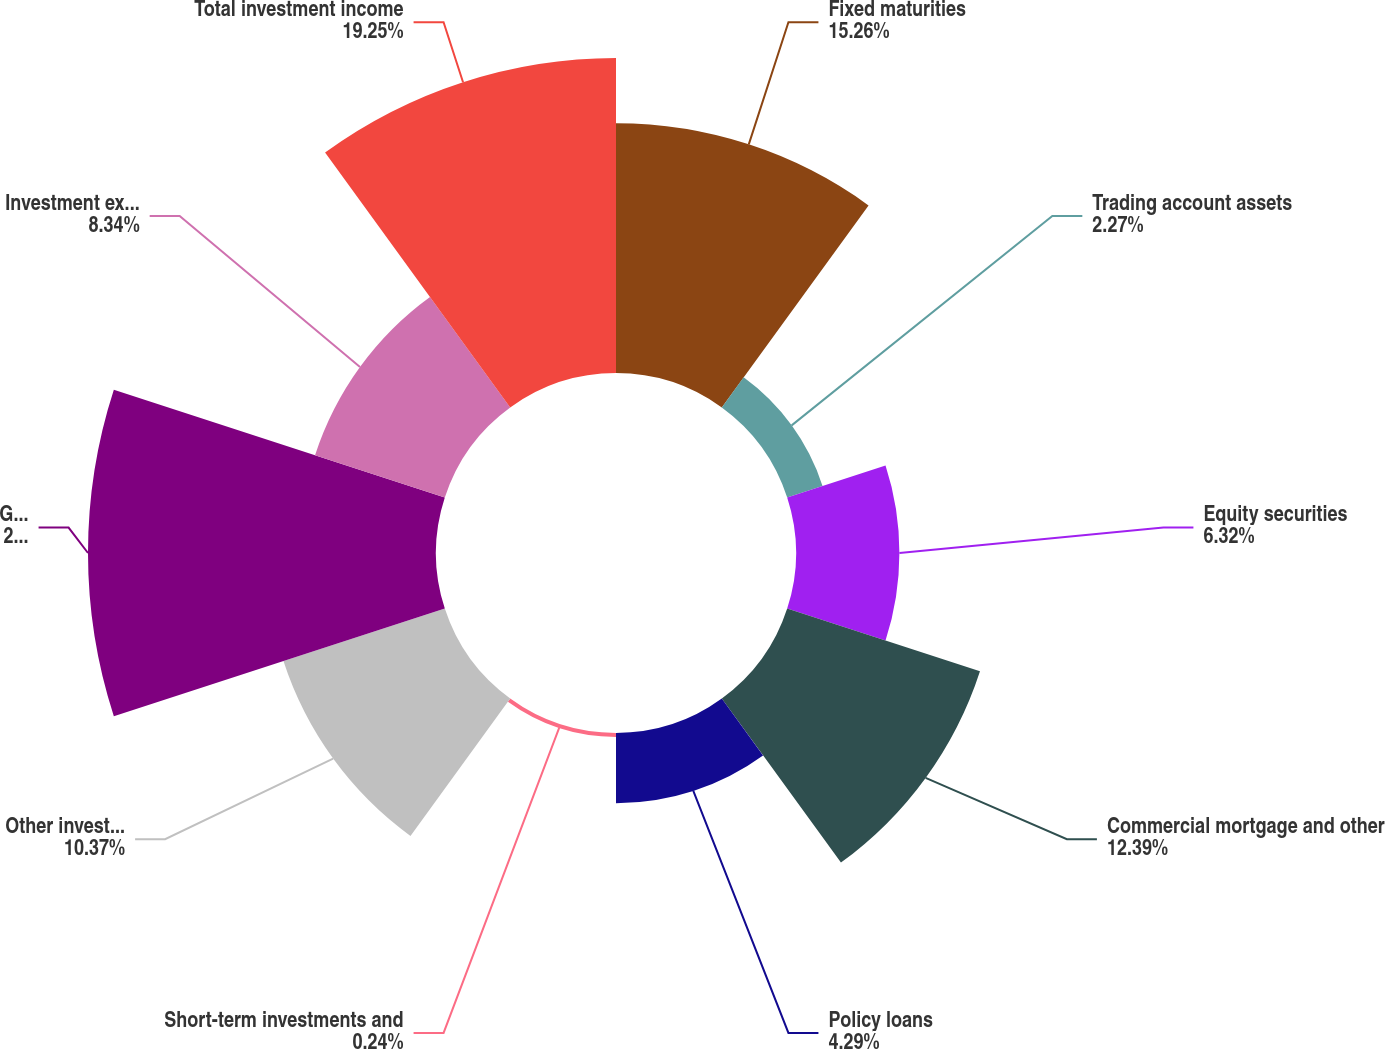<chart> <loc_0><loc_0><loc_500><loc_500><pie_chart><fcel>Fixed maturities<fcel>Trading account assets<fcel>Equity securities<fcel>Commercial mortgage and other<fcel>Policy loans<fcel>Short-term investments and<fcel>Other investments<fcel>Gross investment income before<fcel>Investment expenses<fcel>Total investment income<nl><fcel>15.26%<fcel>2.27%<fcel>6.32%<fcel>12.39%<fcel>4.29%<fcel>0.24%<fcel>10.37%<fcel>21.27%<fcel>8.34%<fcel>19.25%<nl></chart> 